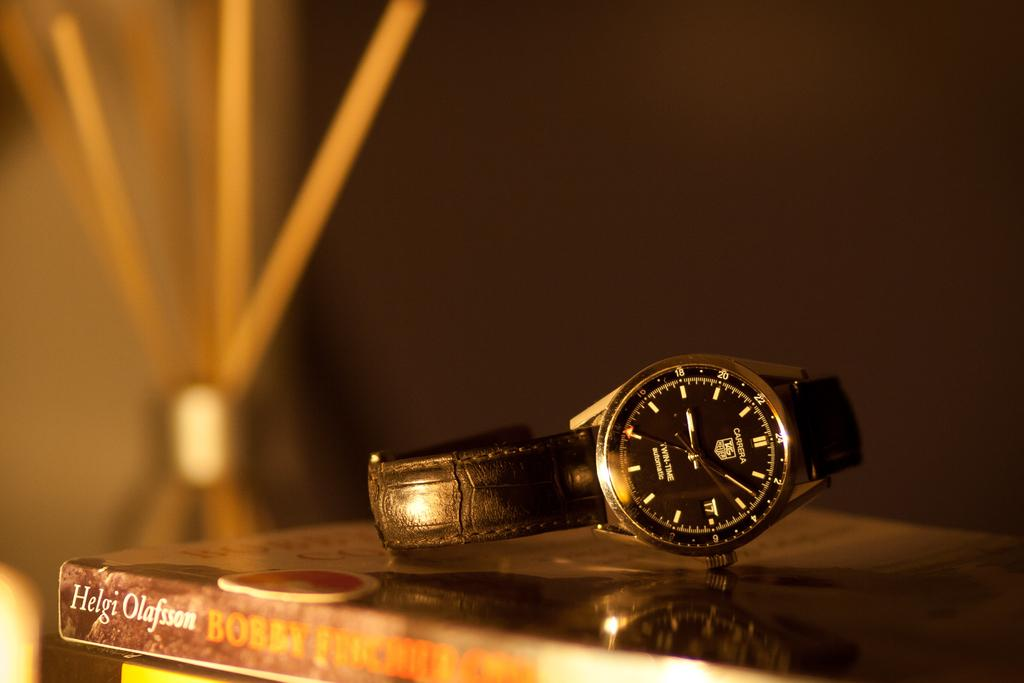<image>
Offer a succinct explanation of the picture presented. A carrera watch rests atop a stack of books. 